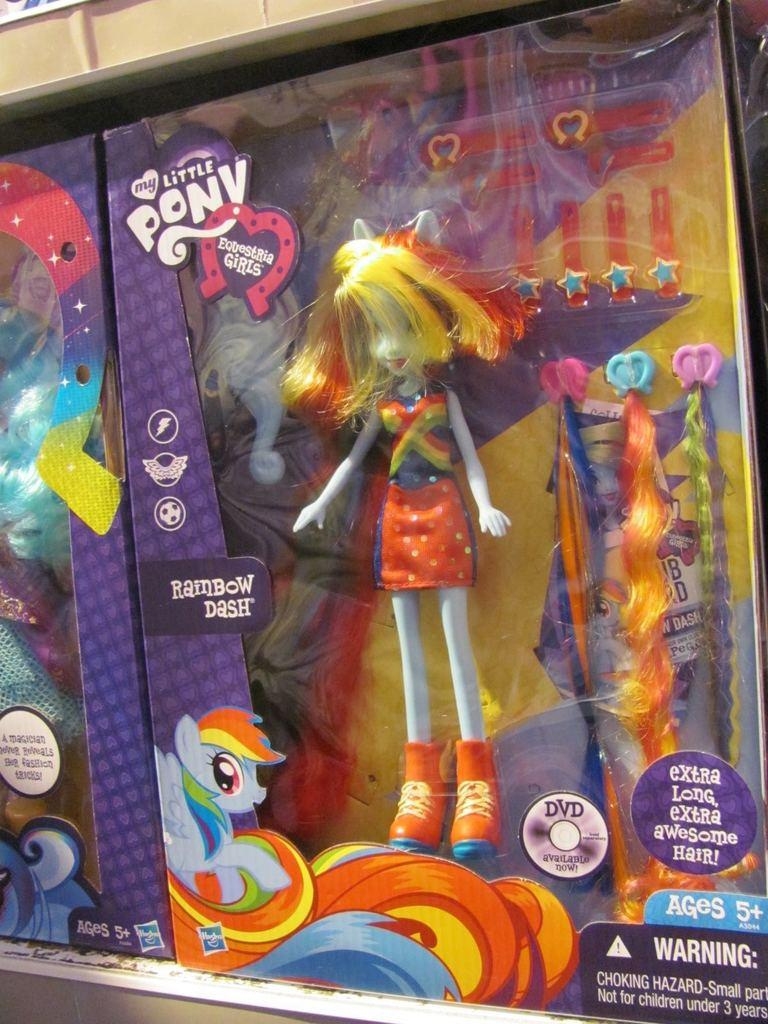How many dolls are in the image? There are two dolls in the image. What accessories are present in the image? Hair extension pins and plastic clips are visible in the image. What are the boxes in the image used for? The boxes contain items, and some of them have stickers on them. Can you see a toothbrush in the image? No, there is no toothbrush present in the image. Is there a collar visible on any of the dolls in the image? No, there are no collars visible on the dolls in the image. 